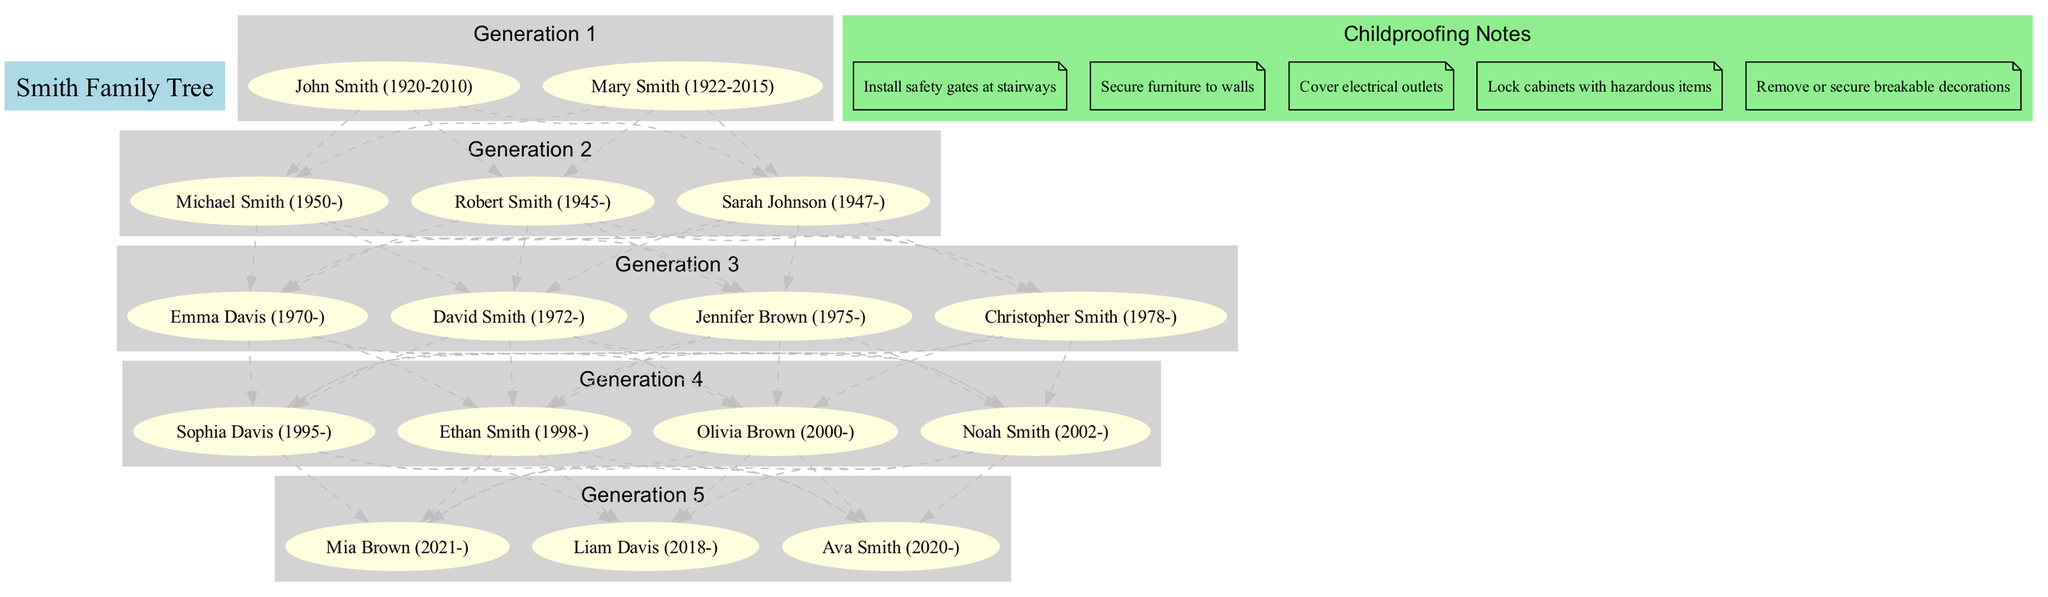What are the names of the first generation members? The first generation comprises John Smith and Mary Smith, who are listed in the "Generation 1" section of the diagram.
Answer: John Smith, Mary Smith How many members are in the third generation? By counting the names in the "Generation 3" section, we see there are four members: Emma Davis, David Smith, Jennifer Brown, and Christopher Smith.
Answer: 4 Who is the oldest member of the family? John Smith, born in 1920, is the oldest member listed in the entire family tree under "Generation 1."
Answer: John Smith Which generation does Ava Smith belong to? Ava Smith is listed under "Generation 5," making her part of the youngest generation in the family tree.
Answer: Generation 5 How many connections are there from Generation 2 to Generation 3? There are three members in Generation 2 connecting to four members in Generation 3; each member can connect to any member in the next generation, resulting in a total of twelve dashed edges depicted in the diagram from the second to the third generation.
Answer: 12 Which notes indicate how to childproof the house from hazardous items? The note that specifically addresses securing hazardous items mentions "Lock cabinets with hazardous items," indicating the necessity of safety measures to protect children from dangerous substances.
Answer: Lock cabinets with hazardous items What is the relationship between Noah Smith and Mary Smith? Mary Smith is the great-grandmother of Noah Smith, as she belongs to Generation 1 while Noah is from Generation 4, creating a three-generation gap between them.
Answer: Great-grandmother How many generations are shown in the family tree? The family tree shows a total of five generations, starting from Generation 1 and continuing to Generation 5, as explicitly listed in the diagram.
Answer: 5 Which member of Generation 4 was born in 2000? The member who was born in 2000 in Generation 4 is Olivia Brown, as noted in the "Generation 4" section.
Answer: Olivia Brown 